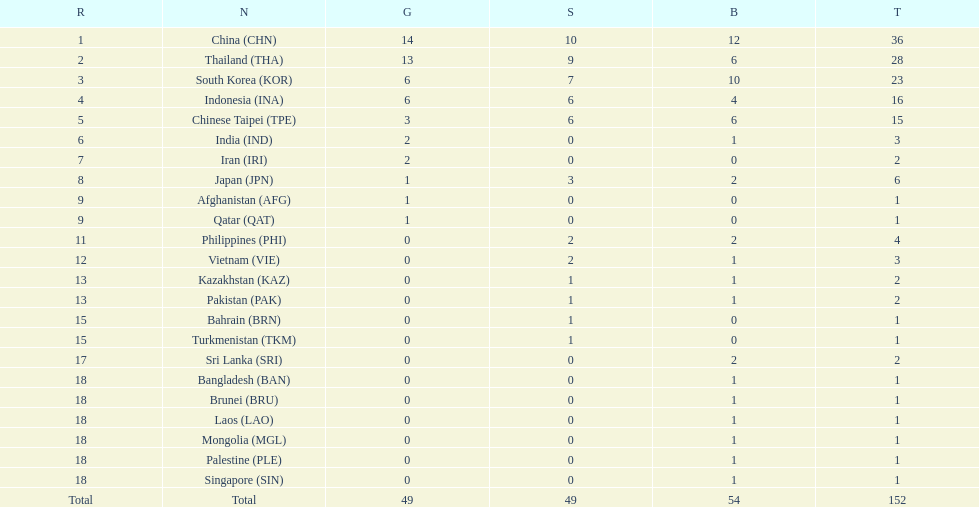What was the number of medals earned by indonesia (ina) ? 16. 